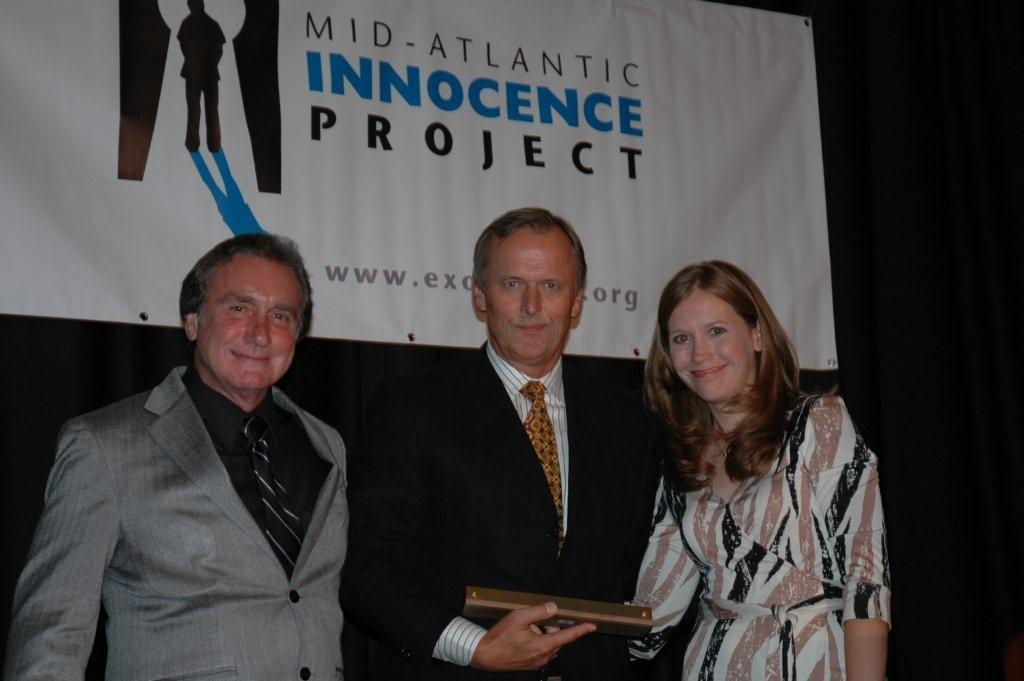What is the main focus of the image? The main focus of the image is the people in the center. Can you describe anything else visible in the image? Yes, there is a poster at the top side of the image. What type of brush is being used in the argument in the image? There is no brush or argument present in the image; it only features people and a poster. 